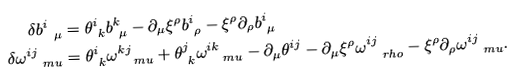<formula> <loc_0><loc_0><loc_500><loc_500>\delta b ^ { i } _ { \ \mu } & = \theta ^ { i } _ { \ k } b ^ { k } _ { \ \mu } - \partial _ { \mu } \xi ^ { \rho } b ^ { i } _ { \ \rho } - \xi ^ { \rho } \partial _ { \rho } b ^ { i } _ { \ \mu } \\ \delta \omega ^ { i j } _ { \quad m u } & = \theta ^ { i } _ { \ k } \omega ^ { k j } _ { \quad m u } + \theta ^ { j } _ { \ k } \omega ^ { i k } _ { \quad m u } - \partial _ { \mu } \theta ^ { i j } - \partial _ { \mu } \xi ^ { \rho } \omega ^ { i j } _ { \quad r h o } - \xi ^ { \rho } \partial _ { \rho } \omega ^ { i j } _ { \quad m u } .</formula> 